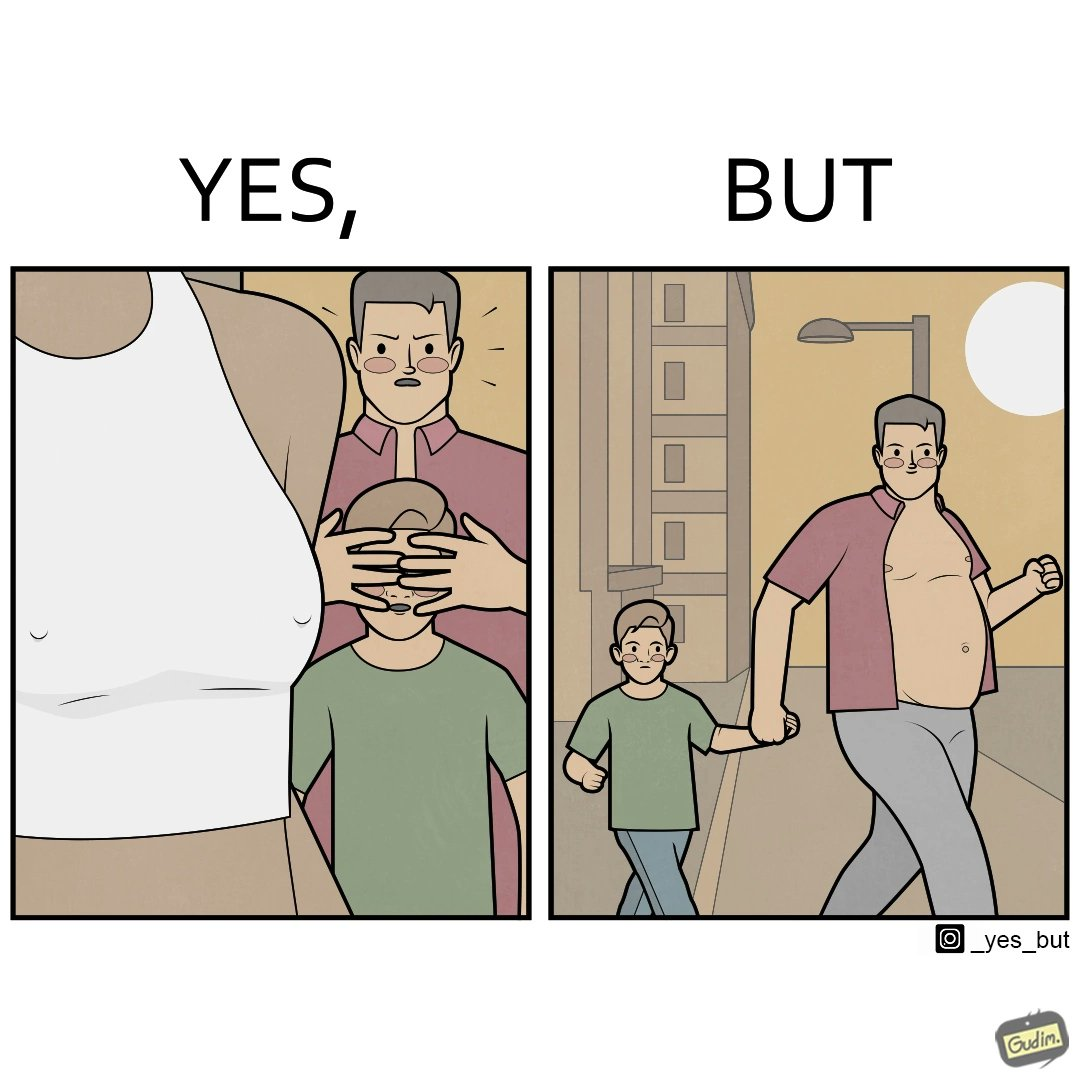Why is this image considered satirical? Although the children is hiding his children's eyes from a women but he himself is roaming in shirt open which is showing his body. 